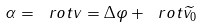Convert formula to latex. <formula><loc_0><loc_0><loc_500><loc_500>\alpha = \ r o t v = \Delta \varphi + \ r o t \widetilde { v _ { 0 } }</formula> 